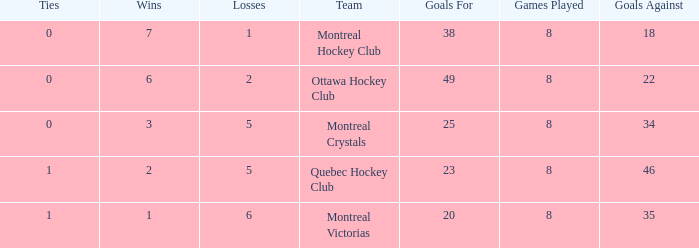What is the highest goals against when the wins is less than 1? None. 